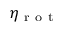Convert formula to latex. <formula><loc_0><loc_0><loc_500><loc_500>\eta _ { r o t }</formula> 